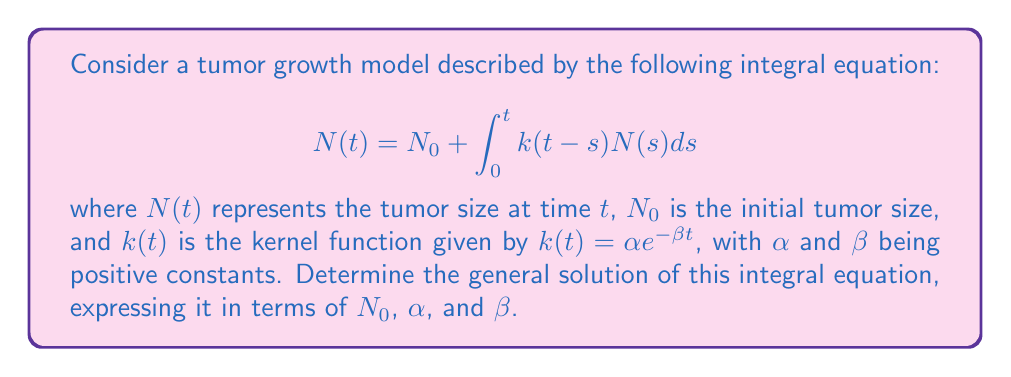Teach me how to tackle this problem. To solve this integral equation, we'll follow these steps:

1) First, we'll take the Laplace transform of both sides of the equation. Let $\mathcal{L}\{N(t)\} = \bar{N}(s)$.

   $$\mathcal{L}\{N(t)\} = \mathcal{L}\{N_0\} + \mathcal{L}\{\int_0^t k(t-s)N(s)ds\}$$

2) Using the properties of Laplace transforms:

   $$\bar{N}(s) = \frac{N_0}{s} + \bar{K}(s)\bar{N}(s)$$

   where $\bar{K}(s)$ is the Laplace transform of $k(t)$.

3) Calculate $\bar{K}(s)$:

   $$\bar{K}(s) = \mathcal{L}\{\alpha e^{-\beta t}\} = \frac{\alpha}{s+\beta}$$

4) Substitute this into the equation from step 2:

   $$\bar{N}(s) = \frac{N_0}{s} + \frac{\alpha}{s+\beta}\bar{N}(s)$$

5) Solve for $\bar{N}(s)$:

   $$\bar{N}(s)(1 - \frac{\alpha}{s+\beta}) = \frac{N_0}{s}$$
   
   $$\bar{N}(s) = \frac{N_0}{s} \cdot \frac{s+\beta}{s+\beta-\alpha}$$

6) Decompose into partial fractions:

   $$\bar{N}(s) = \frac{N_0}{s} + \frac{N_0\beta}{s(s+\beta-\alpha)}$$

7) Take the inverse Laplace transform:

   $$N(t) = N_0 + N_0\beta\int_0^t e^{(\alpha-\beta)u}du$$

8) Evaluate the integral:

   $$N(t) = N_0 + \frac{N_0\beta}{\alpha-\beta}(e^{(\alpha-\beta)t} - 1)$$

9) Simplify:

   $$N(t) = N_0\left(1 + \frac{\beta}{\alpha-\beta}(e^{(\alpha-\beta)t} - 1)\right)$$

This is the general solution of the integral equation.
Answer: $N(t) = N_0\left(1 + \frac{\beta}{\alpha-\beta}(e^{(\alpha-\beta)t} - 1)\right)$ 